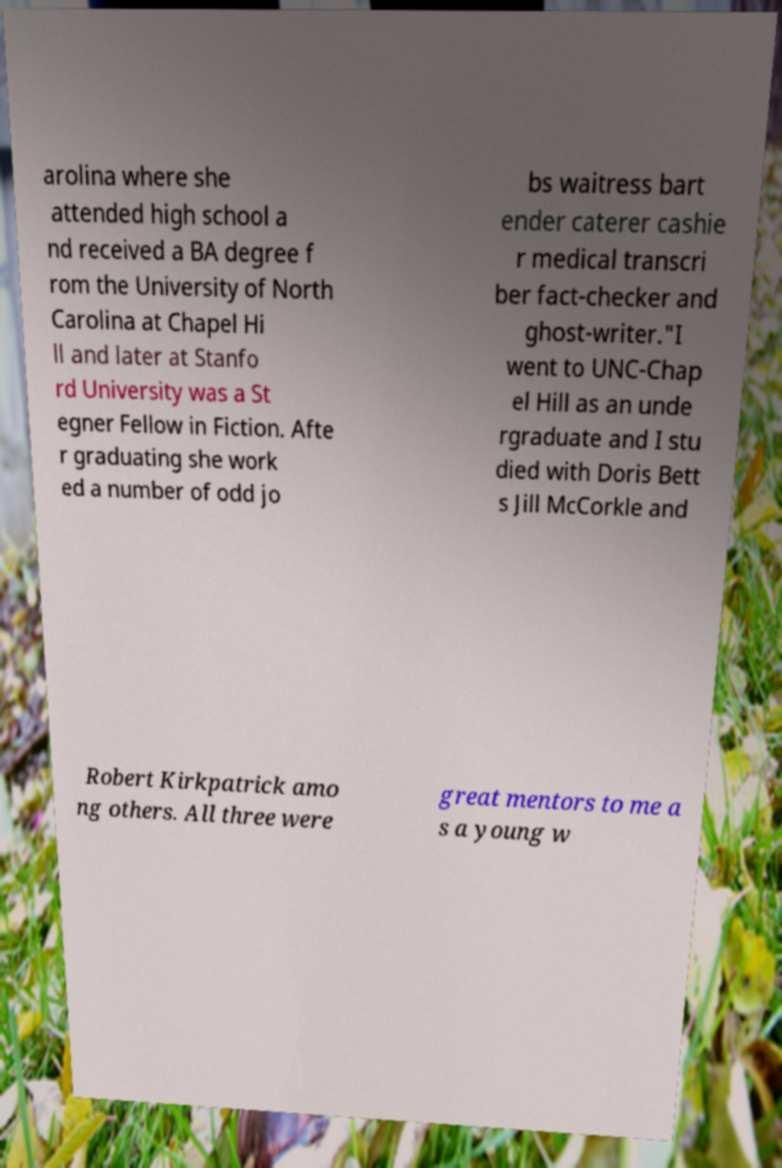Please read and relay the text visible in this image. What does it say? arolina where she attended high school a nd received a BA degree f rom the University of North Carolina at Chapel Hi ll and later at Stanfo rd University was a St egner Fellow in Fiction. Afte r graduating she work ed a number of odd jo bs waitress bart ender caterer cashie r medical transcri ber fact-checker and ghost-writer."I went to UNC-Chap el Hill as an unde rgraduate and I stu died with Doris Bett s Jill McCorkle and Robert Kirkpatrick amo ng others. All three were great mentors to me a s a young w 